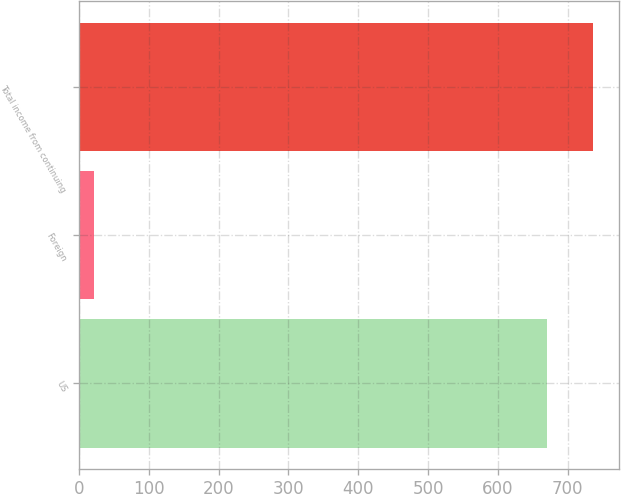<chart> <loc_0><loc_0><loc_500><loc_500><bar_chart><fcel>US<fcel>Foreign<fcel>Total income from continuing<nl><fcel>669.9<fcel>21.1<fcel>736.89<nl></chart> 